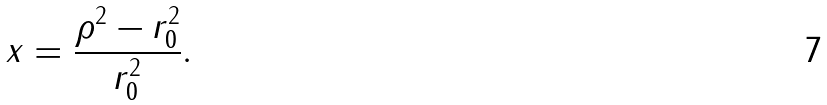Convert formula to latex. <formula><loc_0><loc_0><loc_500><loc_500>x = \frac { \rho ^ { 2 } - r _ { 0 } ^ { 2 } } { r _ { 0 } ^ { 2 } } .</formula> 